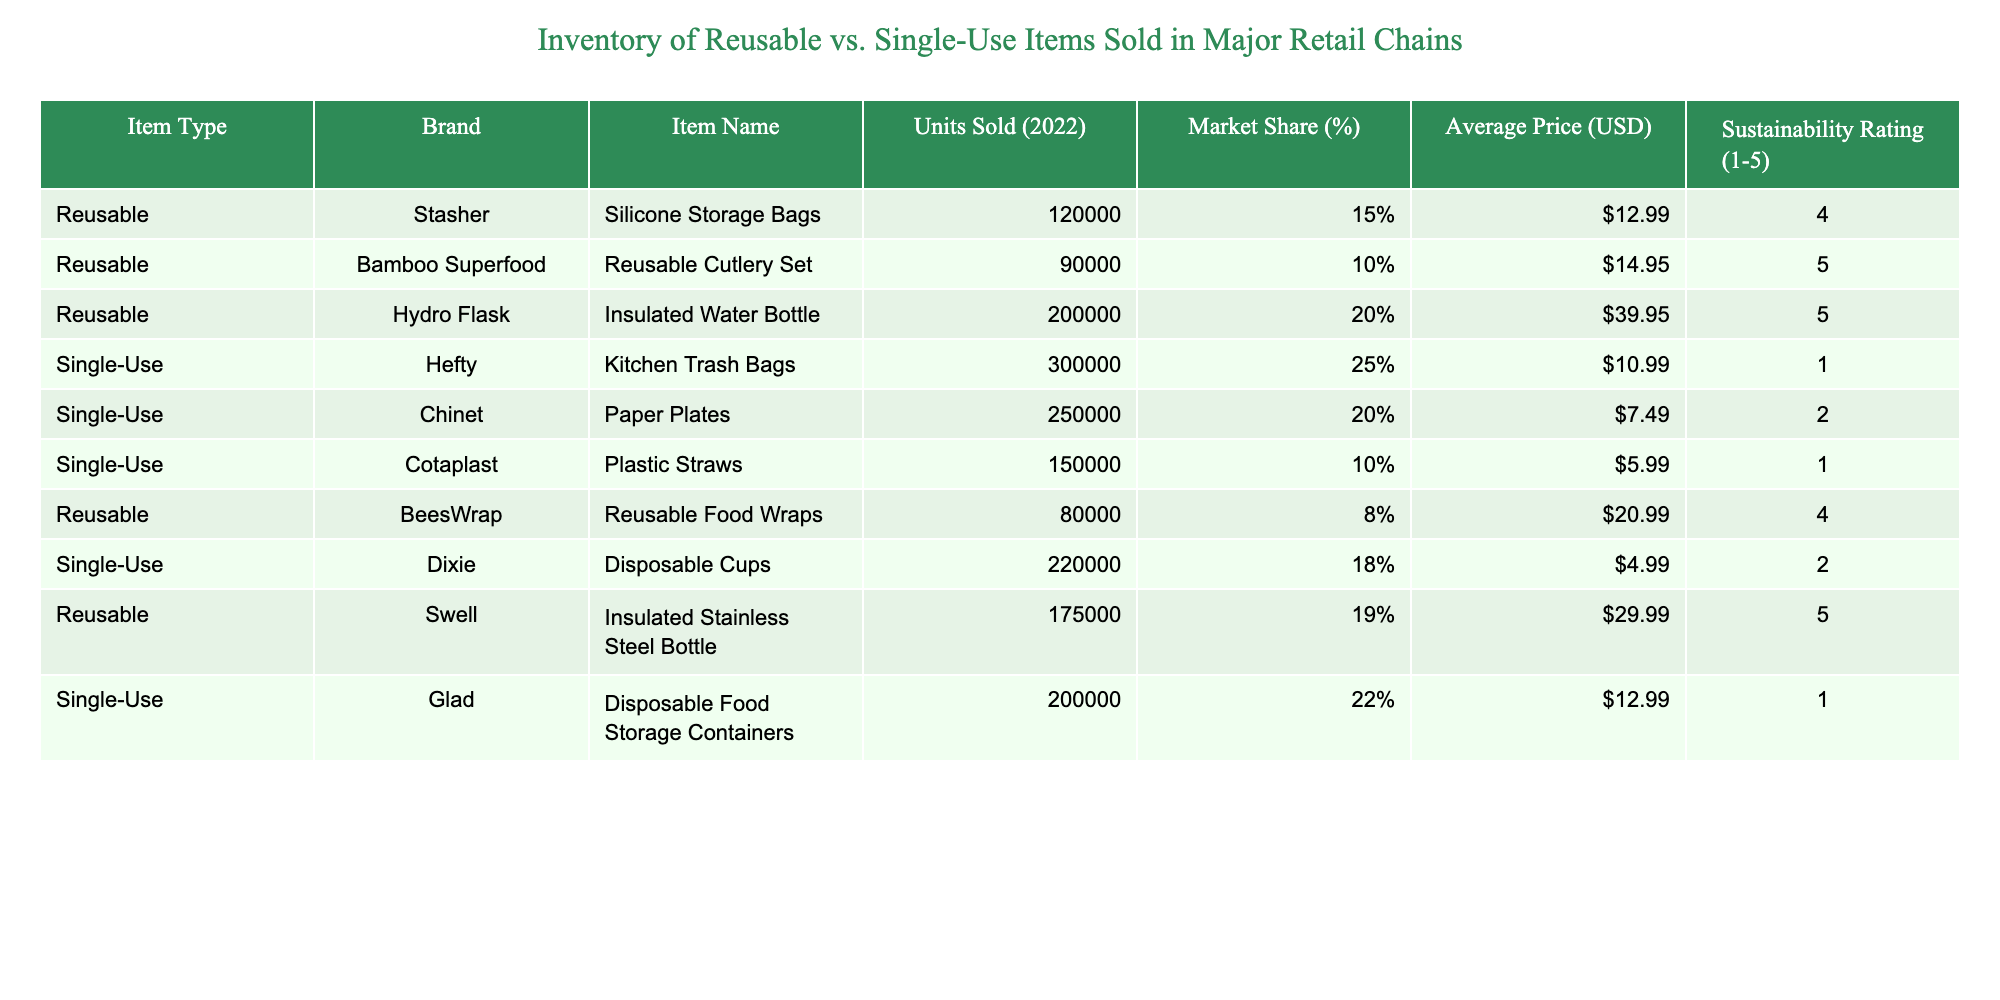What is the total number of Reusable items sold in 2022? To find the total number of Reusable items sold, I will sum the units sold for each Reusable item. The data shows: Silicone Storage Bags (120,000) + Reusable Cutlery Set (90,000) + Insulated Water Bottle (200,000) + Reusable Food Wraps (80,000) + Insulated Stainless Steel Bottle (175,000). The total is 120,000 + 90,000 + 200,000 + 80,000 + 175,000 = 665,000.
Answer: 665,000 Which item has the highest market share among Single-Use items? Looking at the market share percentages for Single-Use items, I see that Kitchen Trash Bags have 25%, which is the highest compared to Paper Plates (20%), Plastic Straws (10%), Disposable Cups (18%), and Disposable Food Storage Containers (22%).
Answer: Kitchen Trash Bags Are all Reusable items rated higher than a Sustainability Rating of 3? The Sustainability Ratings for the Reusable items are: Silicone Storage Bags (4), Reusable Cutlery Set (5), Insulated Water Bottle (5), Reusable Food Wraps (4), and Insulated Stainless Steel Bottle (5). Since all ratings are above 3, the answer is yes.
Answer: Yes What is the average price of all Single-Use items? To calculate the average price of Single-Use items, I will sum their average prices and divide by the number of items. The individual prices are: Kitchen Trash Bags ($10.99), Paper Plates ($7.49), Plastic Straws ($5.99), Disposable Cups ($4.99), and Disposable Food Storage Containers ($12.99). Total price is 10.99 + 7.49 + 5.99 + 4.99 + 12.99 = 42.45. There are 5 items, so the average price is 42.45 / 5 = 8.49.
Answer: 8.49 Which brand offers the least sustainable Single-Use item? The Sustainability Ratings for the Single-Use items are: Kitchen Trash Bags (1), Paper Plates (2), Plastic Straws (1), Disposable Cups (2), and Disposable Food Storage Containers (1). The least sustainable item, therefore, is Kitchen Trash Bags, with a rating of 1, which is the lowest.
Answer: Kitchen Trash Bags 